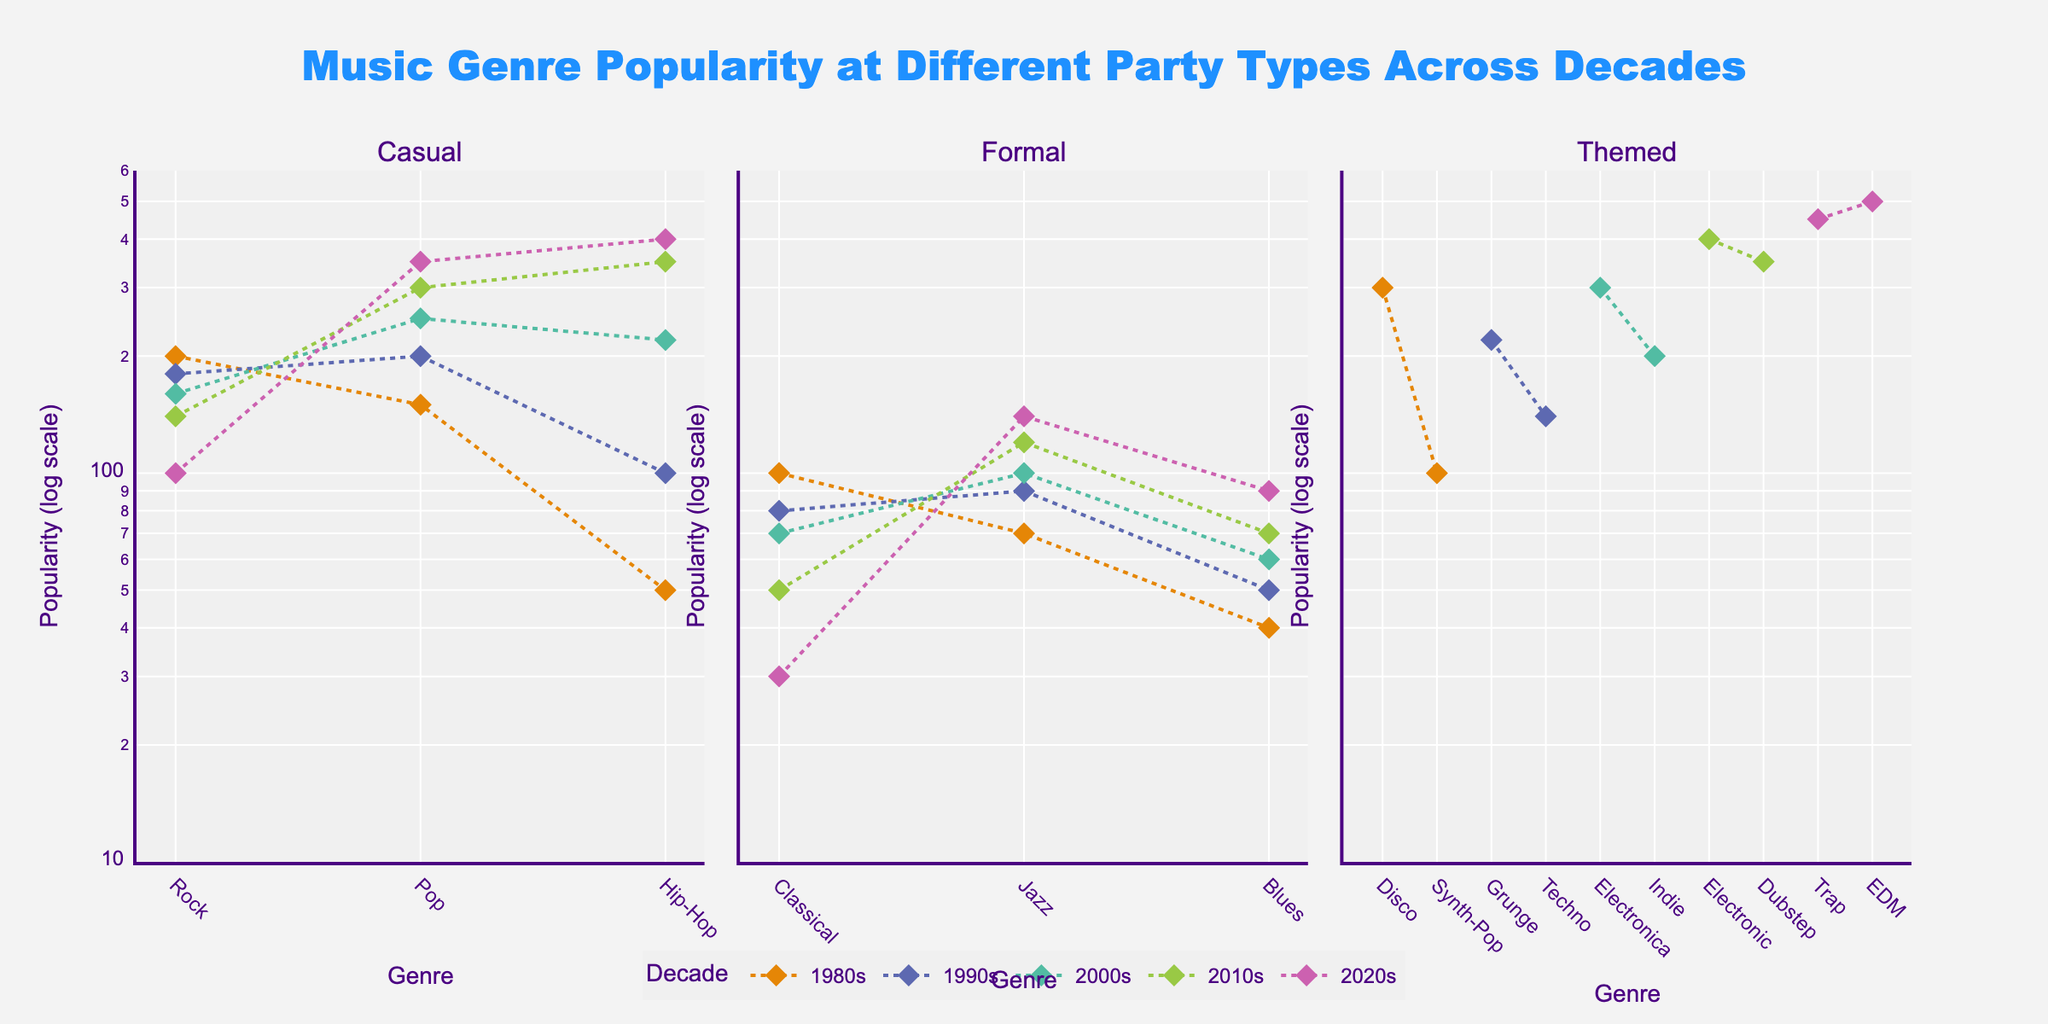What's the title of the plot? The title is located at the top center of the plot. It reads, "Music Genre Popularity at Different Party Types Across Decades".
Answer: Music Genre Popularity at Different Party Types Across Decades Which genre has the highest popularity in themed parties during the 2020s? Look at the subplot for themed parties and refer to the data points for the 2020s. The genre with the highest popularity will be the one plotted at the highest log scale value.
Answer: EDM How does the popularity of Jazz change from the 1980s to the 2020s in formal parties? Locate the data points for Jazz in the subplots for formal parties across the decades from the 1980s to the 2020s. Compare their positions on the log-scale y-axis.
Answer: It increases Is Pop more popular in casual parties in the 2010s or the 2020s? Compare the positions of the Pop data points in the casual party subplot for the 2010s and 2020s. The data point higher on the log-scale y-axis indicates higher popularity.
Answer: 2020s What is the trend in the popularity of Hip-Hop in casual parties from the 1980s to the 2020s? Identify the Hip-Hop data points in casual party subplots for all decades. Determine whether the points move upwards or downwards on the log scale.
Answer: Increasing Compare the popularity of Classical music in formal parties between the 1980s and 2020s, and calculate the ratio. Identify the Classical music data points in the formal party subplots for the 1980s and 2020s. Calculate the ratio using the log-scale values of their popularity.
Answer: Ratio of \( \frac{30}{100} \approx 0.3 \) What's the average popularity of Blues in formal parties over the decades? Identify the Blues data points in formal party subplots across all decades (1980s, 1990s, 2000s, 2010s, 2020s). Sum their popularity values and divide by the number of decades to find the average.
Answer: \( \frac{40 + 50 + 60 + 70 + 90}{5} = 62 \) Which decade has the steepest increase in popularity for Rock in casual parties? Examine the Rock data points in the casual party subplot across all decades. Compare their positional changes on the log scale to determine the steepest positive slope.
Answer: 2010s What is the difference in popularity between Synth-Pop in the 1980s and Indie in the 2000s in themed parties? Locate Synth-Pop in the 1980s and Indie in the 2000s in the themed party subplot. Calculate the difference in their popularity values.
Answer: 100 